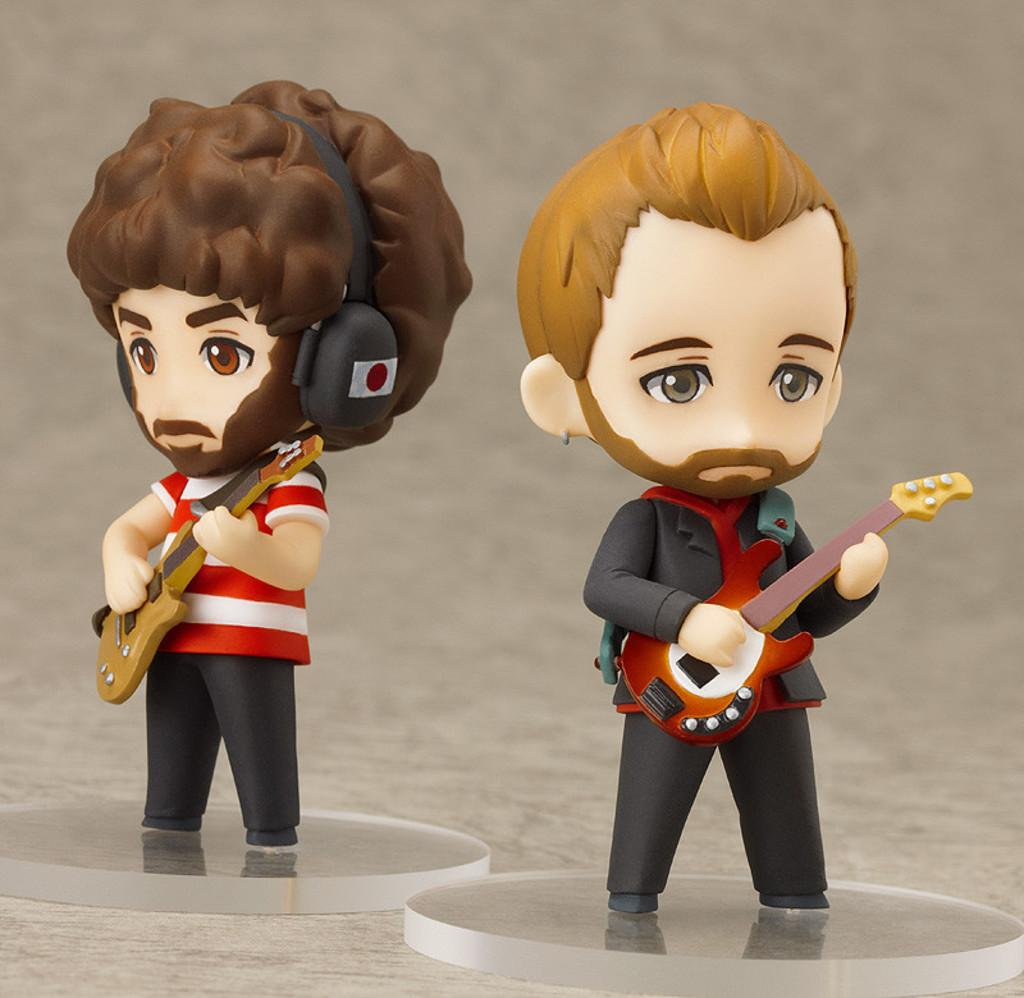What objects are present in the image? There are two toys in the image. What are the toys doing in the image? The toys are holding musical instruments. How can the toys be distinguished from each other? The toys are in different colors. What is the color scheme of the background in the image? The background of the image is in grey and white colors. What type of surprise can be seen in the image? There is no surprise present in the image; it features two toys holding musical instruments. How are the toys maintaining their balance in the image? The toys are not shown performing any balancing act in the image; they are simply holding musical instruments. 